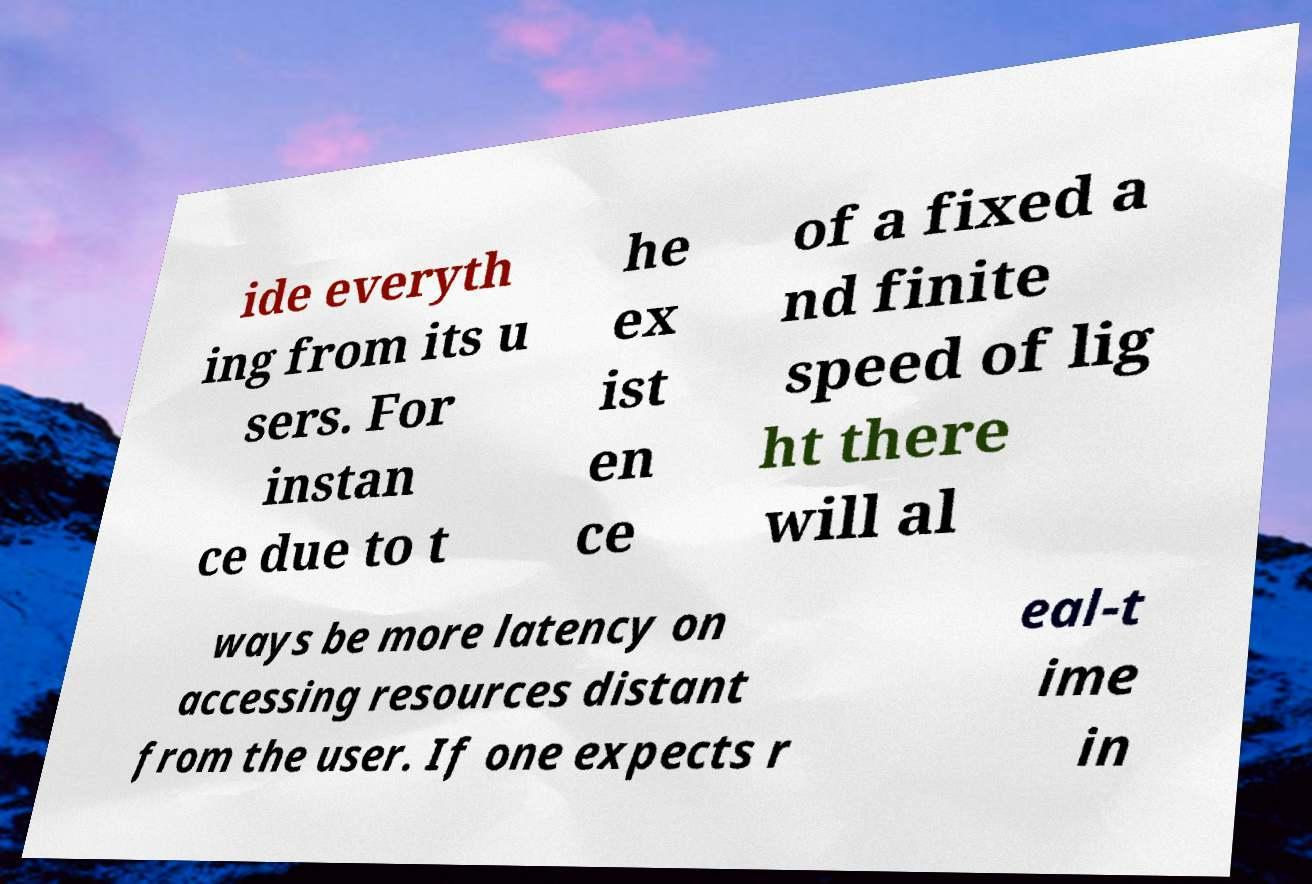Can you read and provide the text displayed in the image?This photo seems to have some interesting text. Can you extract and type it out for me? ide everyth ing from its u sers. For instan ce due to t he ex ist en ce of a fixed a nd finite speed of lig ht there will al ways be more latency on accessing resources distant from the user. If one expects r eal-t ime in 